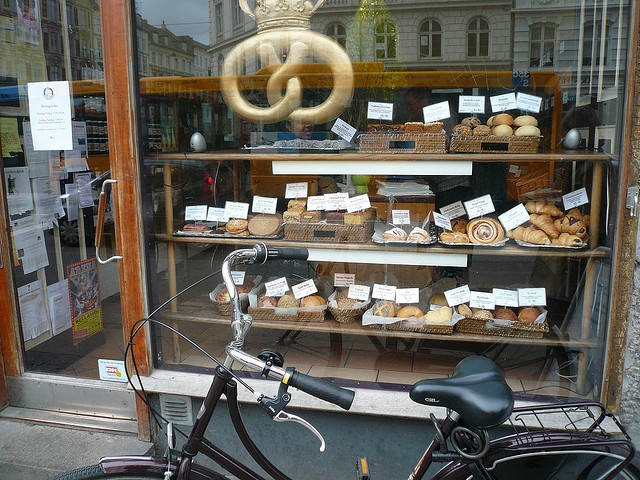Describe the objects in this image and their specific colors. I can see bicycle in black, gray, darkgray, and lightgray tones, people in black and maroon tones, cake in black, gray, and tan tones, donut in black and tan tones, and cake in black, tan, and brown tones in this image. 